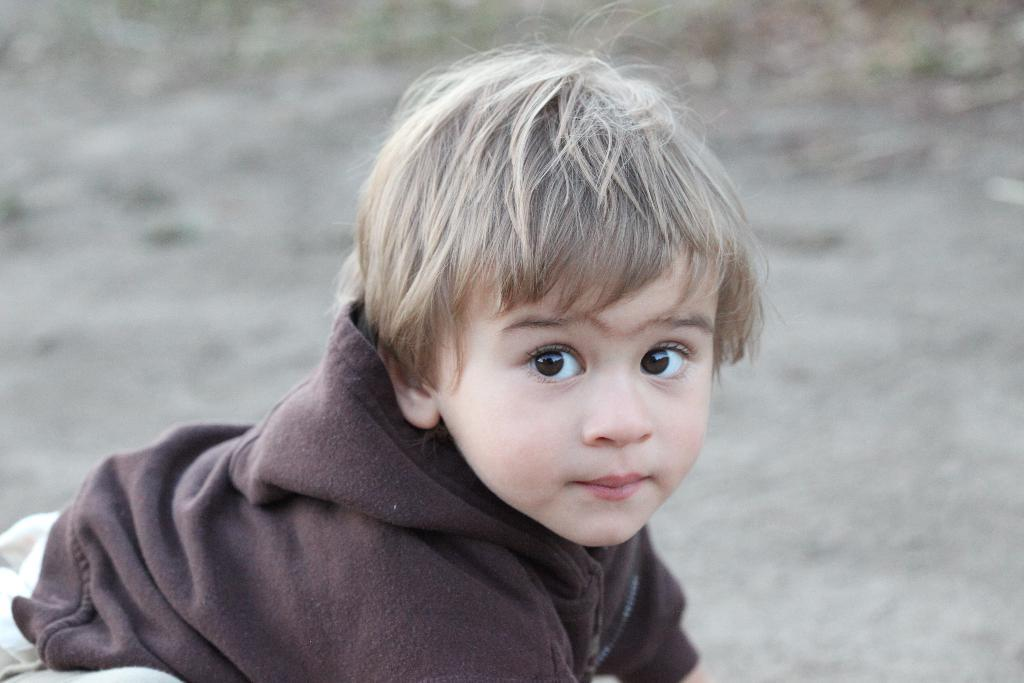What is the main subject of the image? There is a kid in the image. Can you describe the background of the image? The background of the image is blurred. What type of yarn is the cat holding in the image? There is no cat or yarn present in the image; it features a kid with a blurred background. 